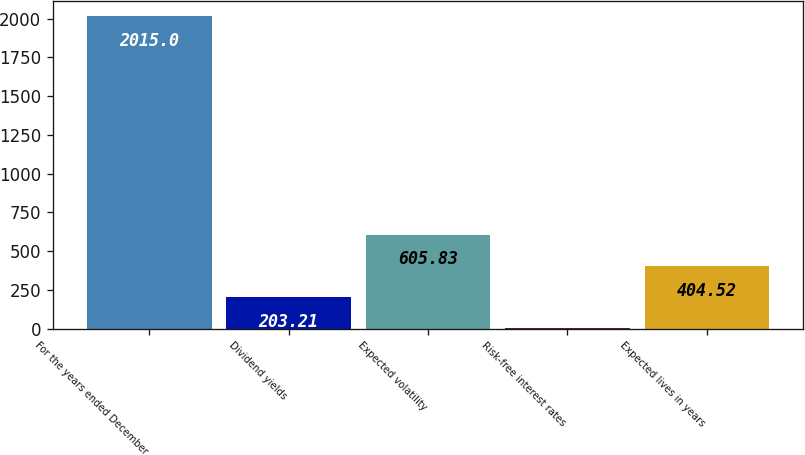<chart> <loc_0><loc_0><loc_500><loc_500><bar_chart><fcel>For the years ended December<fcel>Dividend yields<fcel>Expected volatility<fcel>Risk-free interest rates<fcel>Expected lives in years<nl><fcel>2015<fcel>203.21<fcel>605.83<fcel>1.9<fcel>404.52<nl></chart> 